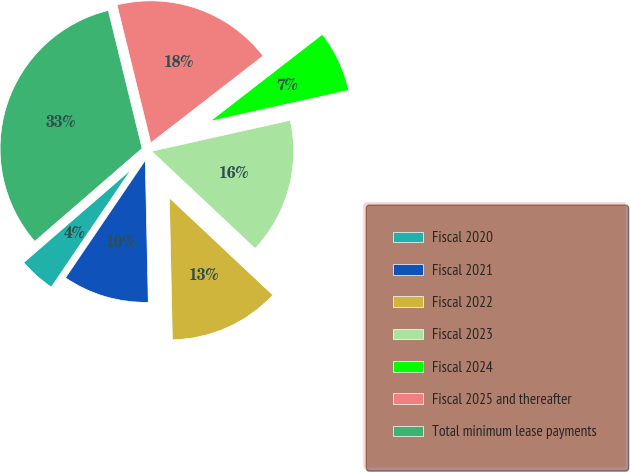<chart> <loc_0><loc_0><loc_500><loc_500><pie_chart><fcel>Fiscal 2020<fcel>Fiscal 2021<fcel>Fiscal 2022<fcel>Fiscal 2023<fcel>Fiscal 2024<fcel>Fiscal 2025 and thereafter<fcel>Total minimum lease payments<nl><fcel>4.15%<fcel>9.83%<fcel>12.66%<fcel>15.5%<fcel>6.99%<fcel>18.34%<fcel>32.53%<nl></chart> 